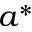<formula> <loc_0><loc_0><loc_500><loc_500>a ^ { * }</formula> 